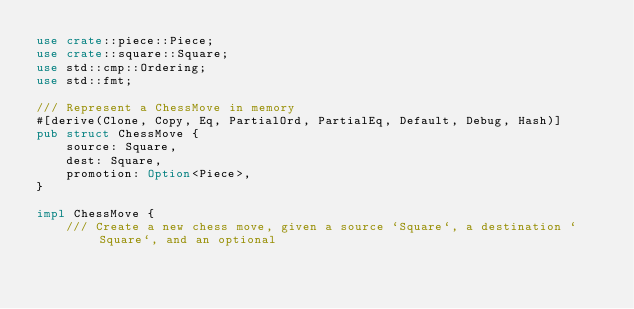<code> <loc_0><loc_0><loc_500><loc_500><_Rust_>use crate::piece::Piece;
use crate::square::Square;
use std::cmp::Ordering;
use std::fmt;

/// Represent a ChessMove in memory
#[derive(Clone, Copy, Eq, PartialOrd, PartialEq, Default, Debug, Hash)]
pub struct ChessMove {
    source: Square,
    dest: Square,
    promotion: Option<Piece>,
}

impl ChessMove {
    /// Create a new chess move, given a source `Square`, a destination `Square`, and an optional</code> 